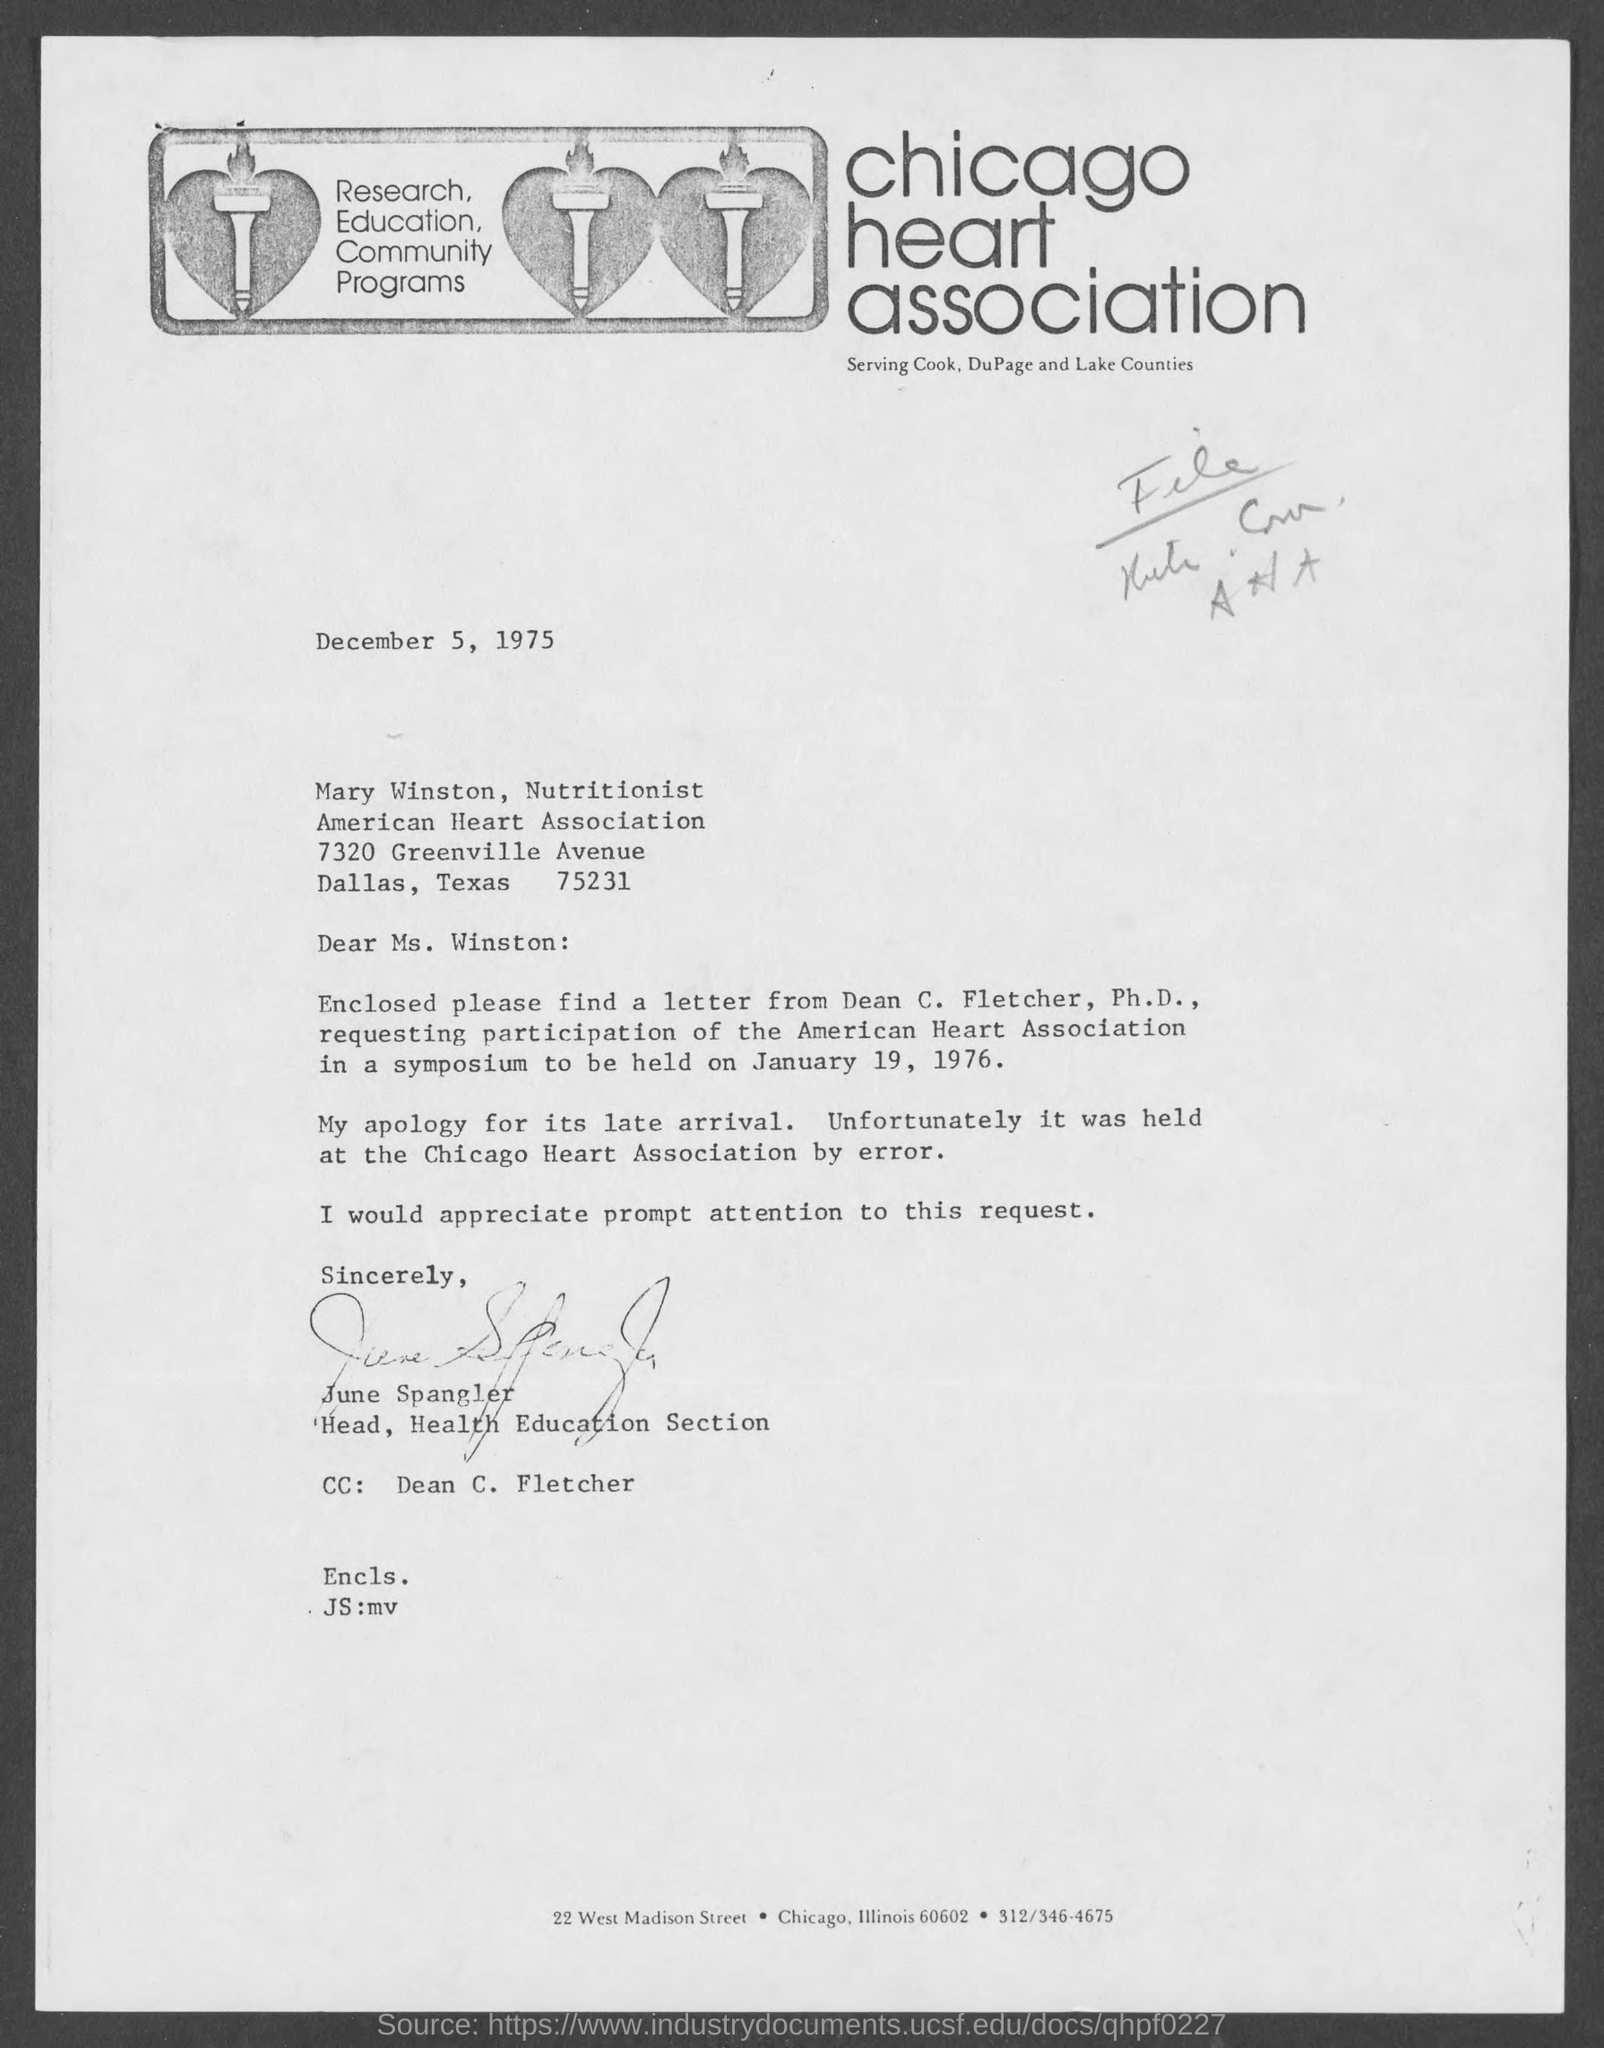Which association is mentioned in the letterhead?
Provide a succinct answer. Chicago Heart Association. What is the issued date of this letter?
Make the answer very short. December 5, 1975. Who has signed the letter?
Provide a short and direct response. June Spangler. What is the designation of June Spangler?
Make the answer very short. Head, Health Education Section. 